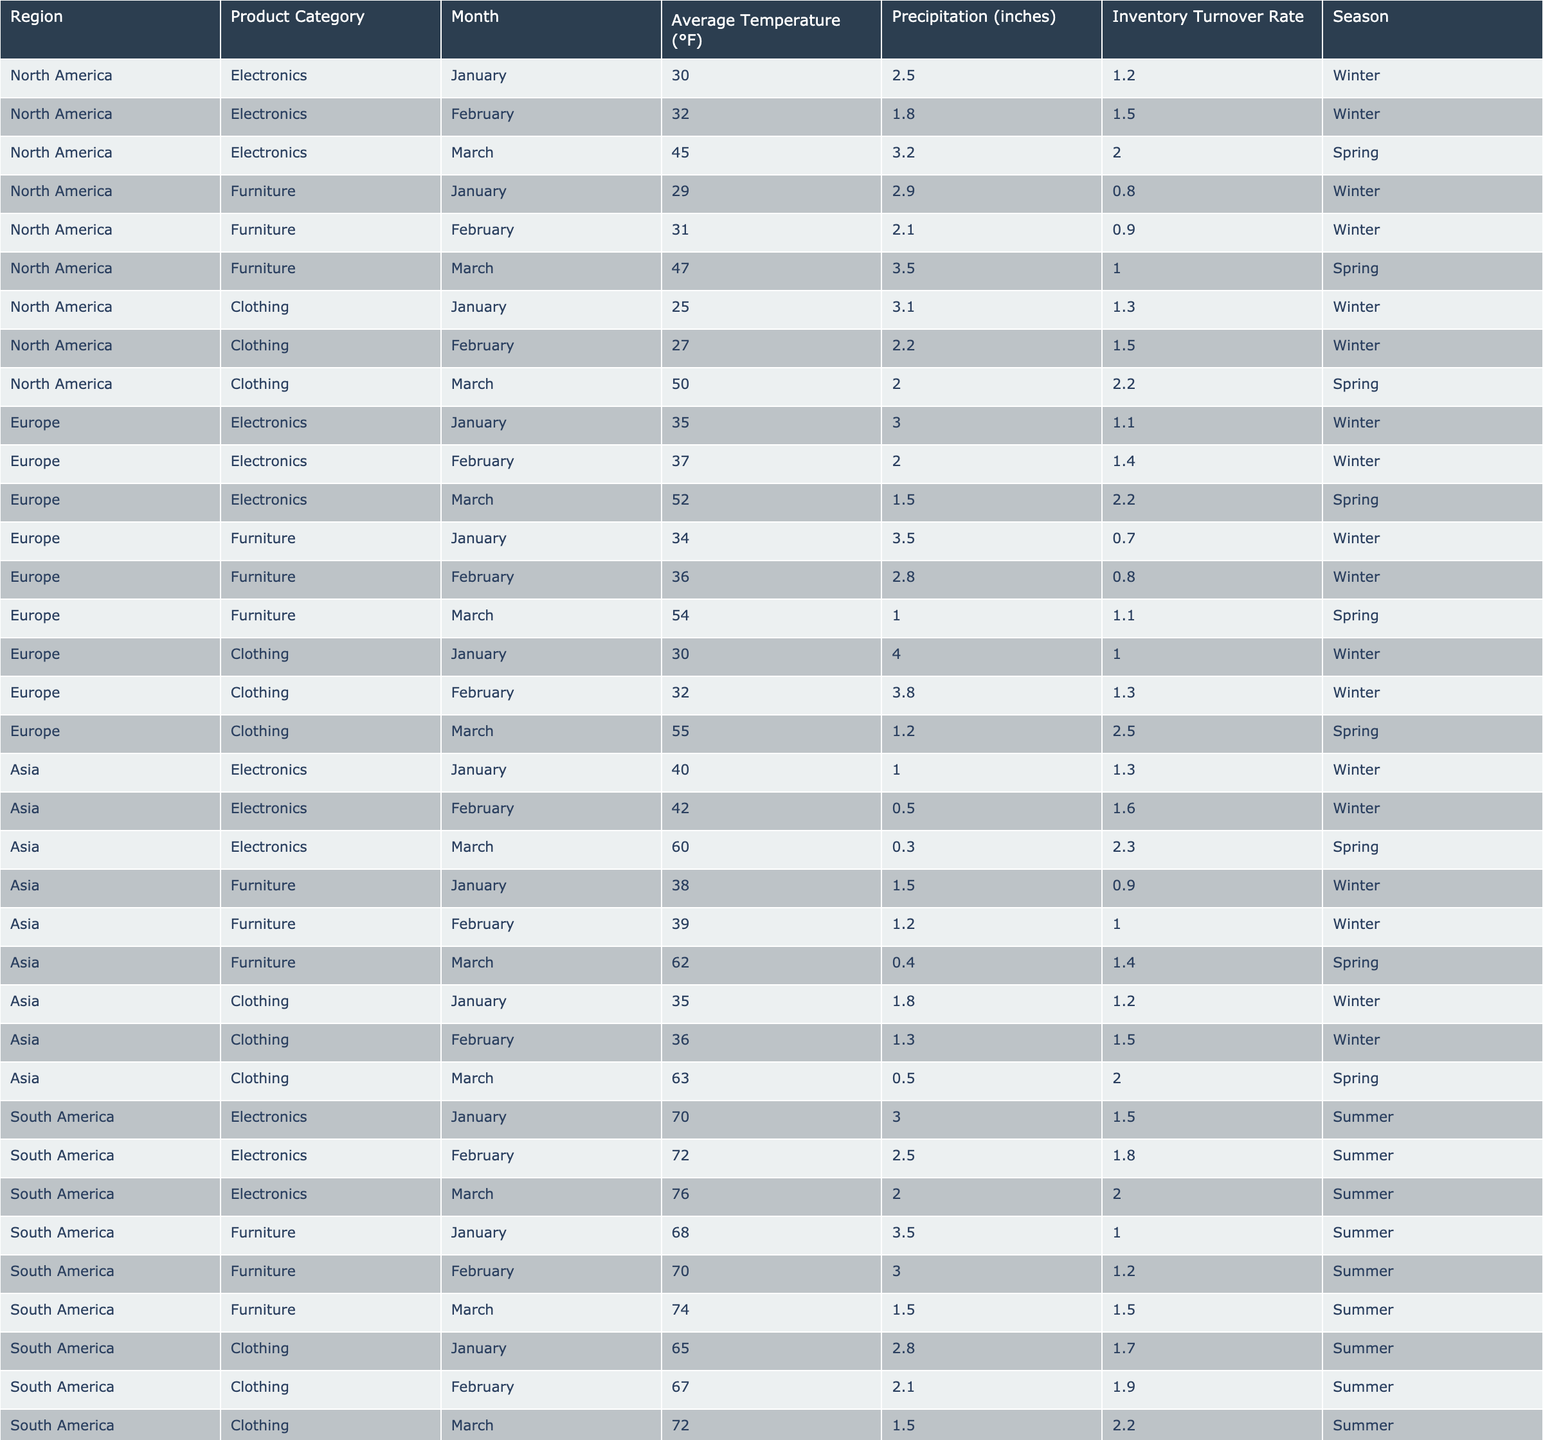What is the inventory turnover rate for Electronics in North America during February? In the table, I look at the North America region under the Electronics category for February, where the inventory turnover rate is listed as 1.5.
Answer: 1.5 Which region has the highest average inventory turnover rate for Clothing in March? I check March data for the Clothing category across all regions. The inventory turnover rates are 2.2 for North America, 2.5 for Europe, and 2.0 for Asia. Europe has the highest rate of 2.5.
Answer: Europe What is the average inventory turnover rate for Furniture in the Winter season across all regions? In the Winter season, the Furniture inventory turnover rates are 0.8, 0.9, 1.0 (North America) and 0.7, 0.8, 1.1 (Europe) and 0.9, 1.0, 1.4 (Asia). The sum is (0.8 + 0.9 + 1.0 + 0.7 + 0.8 + 1.1 + 0.9 + 1.0 + 1.4) = 8.8, and there are 9 data points, so the average is 8.8/9 = 0.98.
Answer: 0.98 Is the inventory turnover rate for Electronics in Asia higher in February or March? In the table, for Asia, the inventory turnover rate for Electronics in February is 1.6 and in March it is 2.3. Since 2.3 is greater than 1.6, March has a higher turnover rate.
Answer: March What is the total inventory turnover rate for Electronics across all regions in January? I look at the January data for Electronics: North America 1.2, Europe 1.1, Asia 1.3, and South America 1.5. The total is (1.2 + 1.1 + 1.3 + 1.5) = 5.1.
Answer: 5.1 What is the difference in inventory turnover rates for Clothing between North America and Europe in February? In February, North America has a Clothing inventory turnover rate of 1.5, while Europe has 1.3. The difference is calculated as 1.5 - 1.3 = 0.2.
Answer: 0.2 Which product category in South America has the highest inventory turnover rate in March? I check the March data for South America: for Electronics it’s 2.0, for Furniture it’s 1.5, and for Clothing it’s 2.2. The highest is 2.2 for Clothing.
Answer: Clothing Does inventory turnover for Furniture improve in the Spring in North America? In the table, North America’s inventory turnover rate for Furniture is 0.8 in January, 0.9 in February, and it increases to 1.0 in March (Spring), indicating improvement.
Answer: Yes What is the regional difference in average inventory turnover rates for Electronics between North America and Europe in March? In March, North America has an Electronics turnover rate of 2.0, while Europe has 2.2. The difference is 2.2 - 2.0 = 0.2.
Answer: 0.2 What trend can be observed for the Clothing inventory turnover rates from January to March across all regions? I evaluate the Clothing turnover rates: North America (1.3 to 2.2), Europe (1.0 to 2.5), Asia (1.2 to 2.0), and South America (1.7 to 2.2). All regions show an increase from January to March, indicating a positive trend.
Answer: Positive trend 